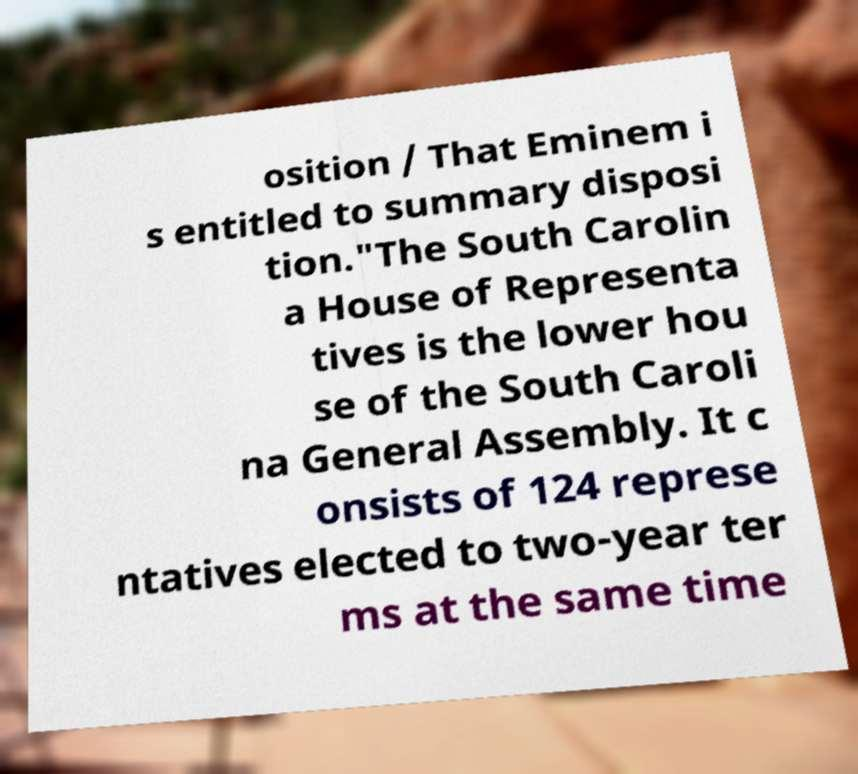Could you assist in decoding the text presented in this image and type it out clearly? osition / That Eminem i s entitled to summary disposi tion."The South Carolin a House of Representa tives is the lower hou se of the South Caroli na General Assembly. It c onsists of 124 represe ntatives elected to two-year ter ms at the same time 